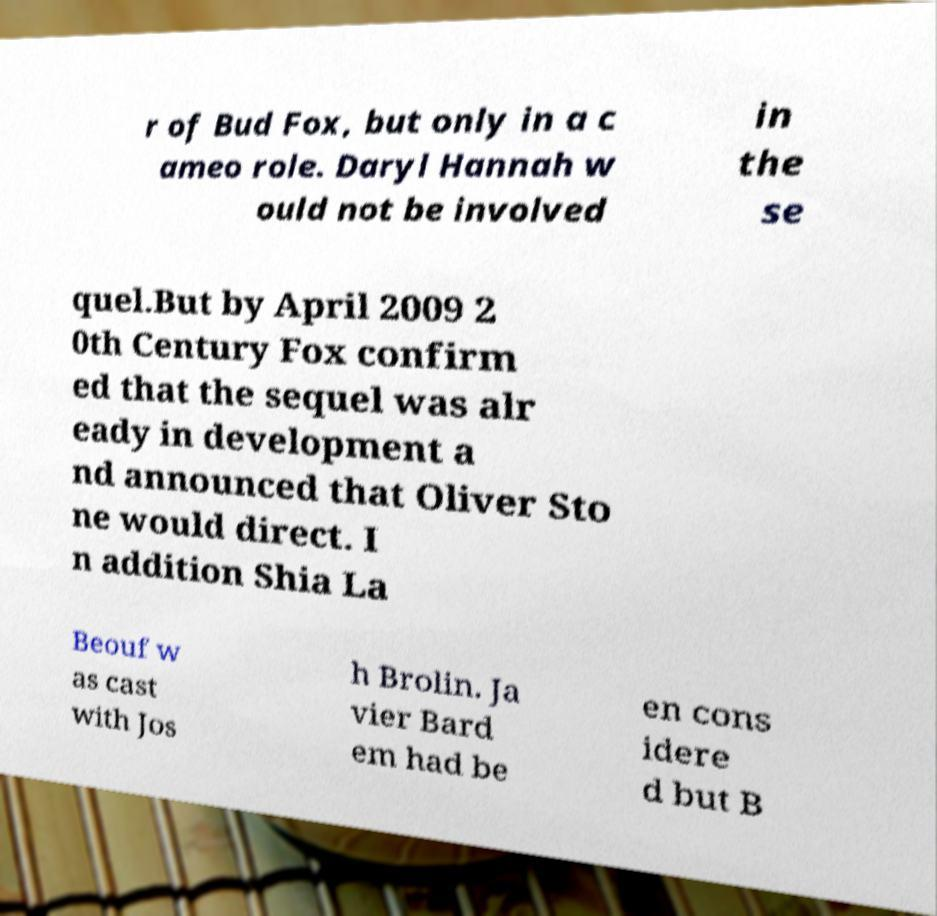There's text embedded in this image that I need extracted. Can you transcribe it verbatim? r of Bud Fox, but only in a c ameo role. Daryl Hannah w ould not be involved in the se quel.But by April 2009 2 0th Century Fox confirm ed that the sequel was alr eady in development a nd announced that Oliver Sto ne would direct. I n addition Shia La Beouf w as cast with Jos h Brolin. Ja vier Bard em had be en cons idere d but B 